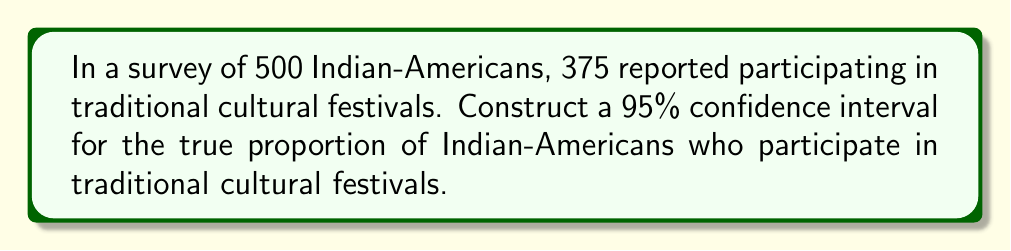Could you help me with this problem? Let's construct the confidence interval step-by-step:

1. Identify the sample proportion:
   $\hat{p} = \frac{375}{500} = 0.75$

2. Calculate the standard error:
   $SE = \sqrt{\frac{\hat{p}(1-\hat{p})}{n}} = \sqrt{\frac{0.75(1-0.75)}{500}} = \sqrt{\frac{0.1875}{500}} = 0.0194$

3. For a 95% confidence interval, use $z^* = 1.96$

4. Calculate the margin of error:
   $ME = z^* \cdot SE = 1.96 \cdot 0.0194 = 0.0380$

5. Construct the confidence interval:
   $CI = \hat{p} \pm ME$
   $CI = 0.75 \pm 0.0380$
   $CI = (0.7120, 0.7880)$

Therefore, we can be 95% confident that the true proportion of Indian-Americans who participate in traditional cultural festivals is between 0.7120 and 0.7880, or between 71.20% and 78.80%.
Answer: (0.7120, 0.7880) 